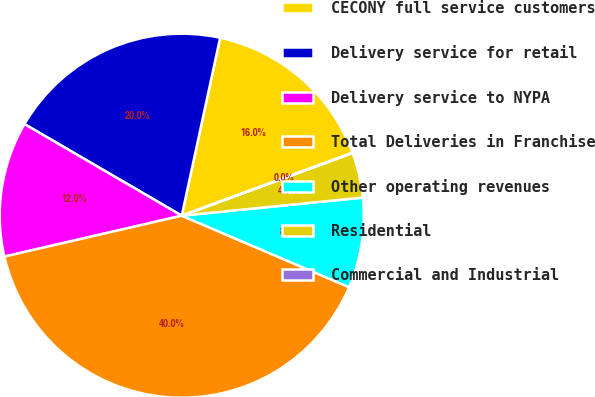<chart> <loc_0><loc_0><loc_500><loc_500><pie_chart><fcel>CECONY full service customers<fcel>Delivery service for retail<fcel>Delivery service to NYPA<fcel>Total Deliveries in Franchise<fcel>Other operating revenues<fcel>Residential<fcel>Commercial and Industrial<nl><fcel>16.0%<fcel>19.99%<fcel>12.0%<fcel>39.97%<fcel>8.01%<fcel>4.01%<fcel>0.02%<nl></chart> 